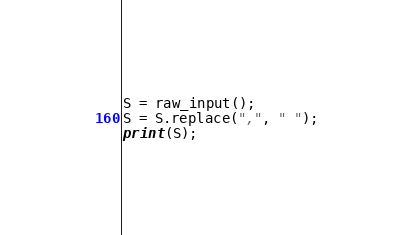Convert code to text. <code><loc_0><loc_0><loc_500><loc_500><_Python_>S = raw_input();
S = S.replace(",", " ");
print(S);</code> 